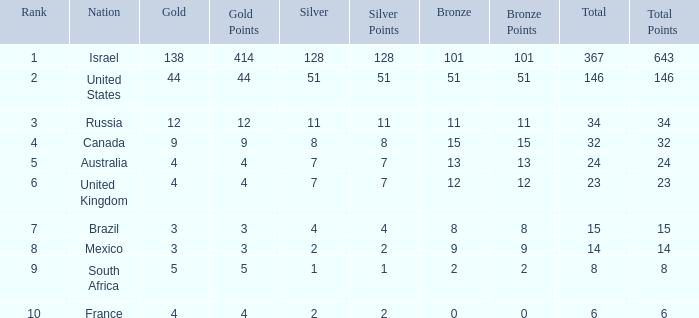What is the gold medal count for the country with a total greater than 32 and more than 128 silvers? None. 